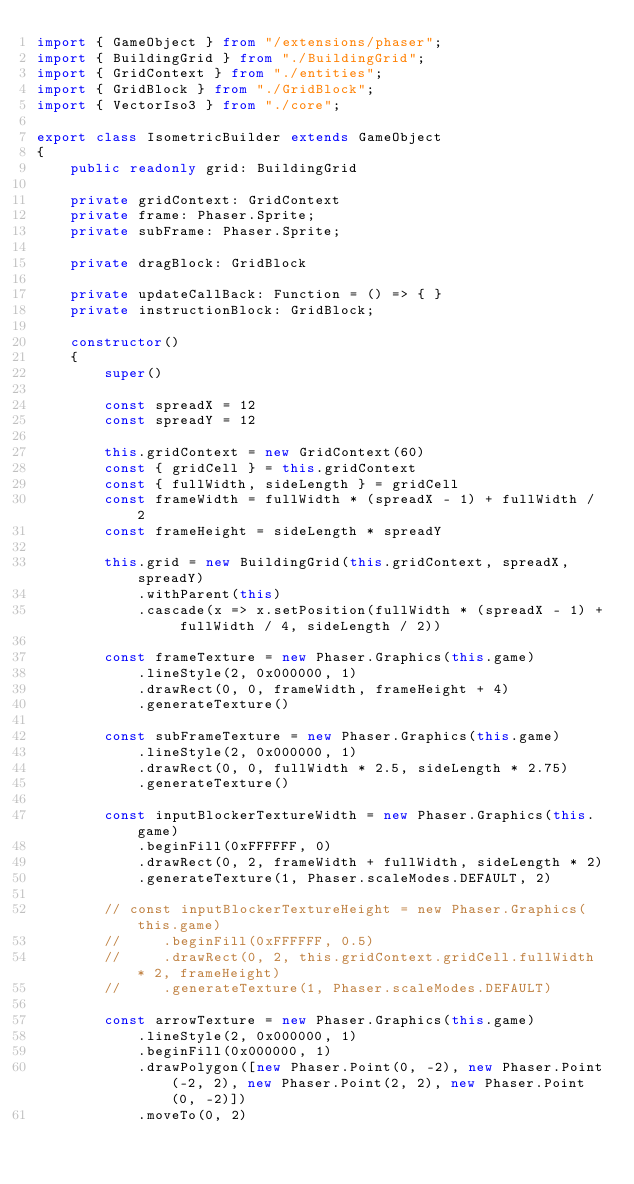Convert code to text. <code><loc_0><loc_0><loc_500><loc_500><_TypeScript_>import { GameObject } from "/extensions/phaser";
import { BuildingGrid } from "./BuildingGrid";
import { GridContext } from "./entities";
import { GridBlock } from "./GridBlock";
import { VectorIso3 } from "./core";

export class IsometricBuilder extends GameObject
{
    public readonly grid: BuildingGrid

    private gridContext: GridContext
    private frame: Phaser.Sprite;
    private subFrame: Phaser.Sprite;

    private dragBlock: GridBlock

    private updateCallBack: Function = () => { }
    private instructionBlock: GridBlock;

    constructor()
    {
        super()

        const spreadX = 12
        const spreadY = 12

        this.gridContext = new GridContext(60)
        const { gridCell } = this.gridContext
        const { fullWidth, sideLength } = gridCell
        const frameWidth = fullWidth * (spreadX - 1) + fullWidth / 2
        const frameHeight = sideLength * spreadY

        this.grid = new BuildingGrid(this.gridContext, spreadX, spreadY)
            .withParent(this)
            .cascade(x => x.setPosition(fullWidth * (spreadX - 1) + fullWidth / 4, sideLength / 2))

        const frameTexture = new Phaser.Graphics(this.game)
            .lineStyle(2, 0x000000, 1)
            .drawRect(0, 0, frameWidth, frameHeight + 4)
            .generateTexture()

        const subFrameTexture = new Phaser.Graphics(this.game)
            .lineStyle(2, 0x000000, 1)
            .drawRect(0, 0, fullWidth * 2.5, sideLength * 2.75)
            .generateTexture()

        const inputBlockerTextureWidth = new Phaser.Graphics(this.game)
            .beginFill(0xFFFFFF, 0)
            .drawRect(0, 2, frameWidth + fullWidth, sideLength * 2)
            .generateTexture(1, Phaser.scaleModes.DEFAULT, 2)

        // const inputBlockerTextureHeight = new Phaser.Graphics(this.game)
        //     .beginFill(0xFFFFFF, 0.5)
        //     .drawRect(0, 2, this.gridContext.gridCell.fullWidth * 2, frameHeight)
        //     .generateTexture(1, Phaser.scaleModes.DEFAULT)

        const arrowTexture = new Phaser.Graphics(this.game)
            .lineStyle(2, 0x000000, 1)
            .beginFill(0x000000, 1)
            .drawPolygon([new Phaser.Point(0, -2), new Phaser.Point(-2, 2), new Phaser.Point(2, 2), new Phaser.Point(0, -2)])
            .moveTo(0, 2)</code> 